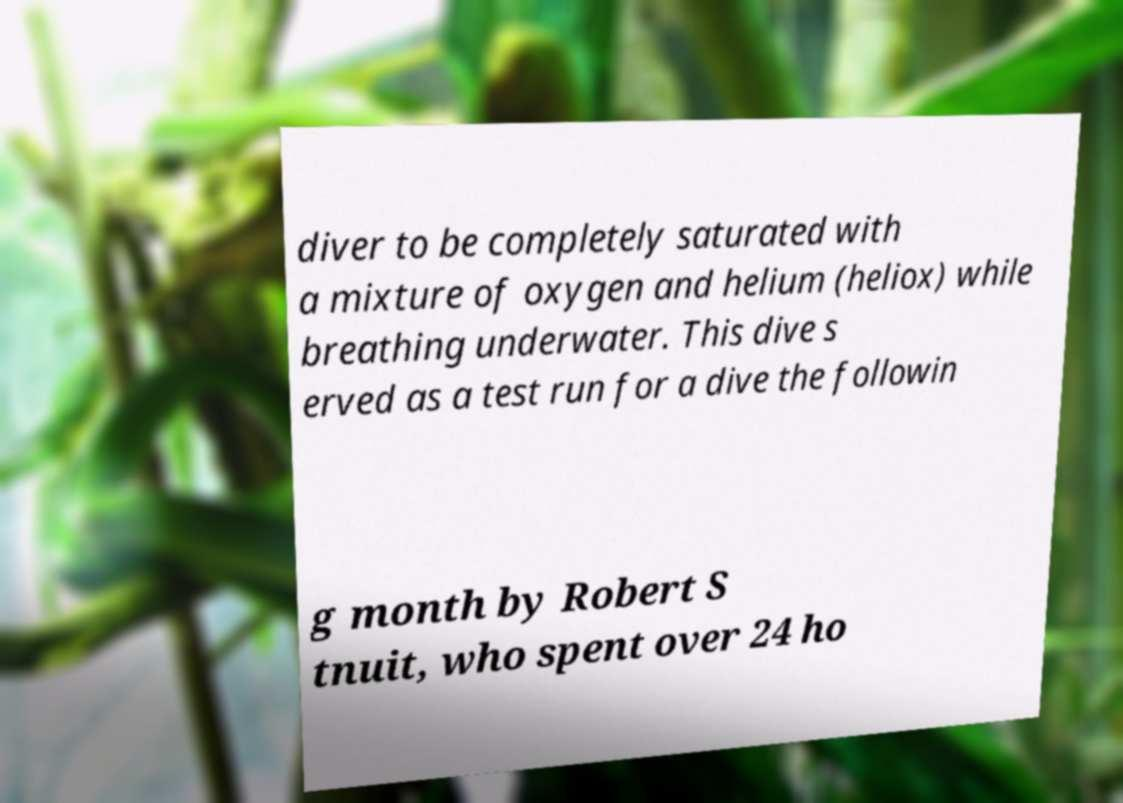There's text embedded in this image that I need extracted. Can you transcribe it verbatim? diver to be completely saturated with a mixture of oxygen and helium (heliox) while breathing underwater. This dive s erved as a test run for a dive the followin g month by Robert S tnuit, who spent over 24 ho 